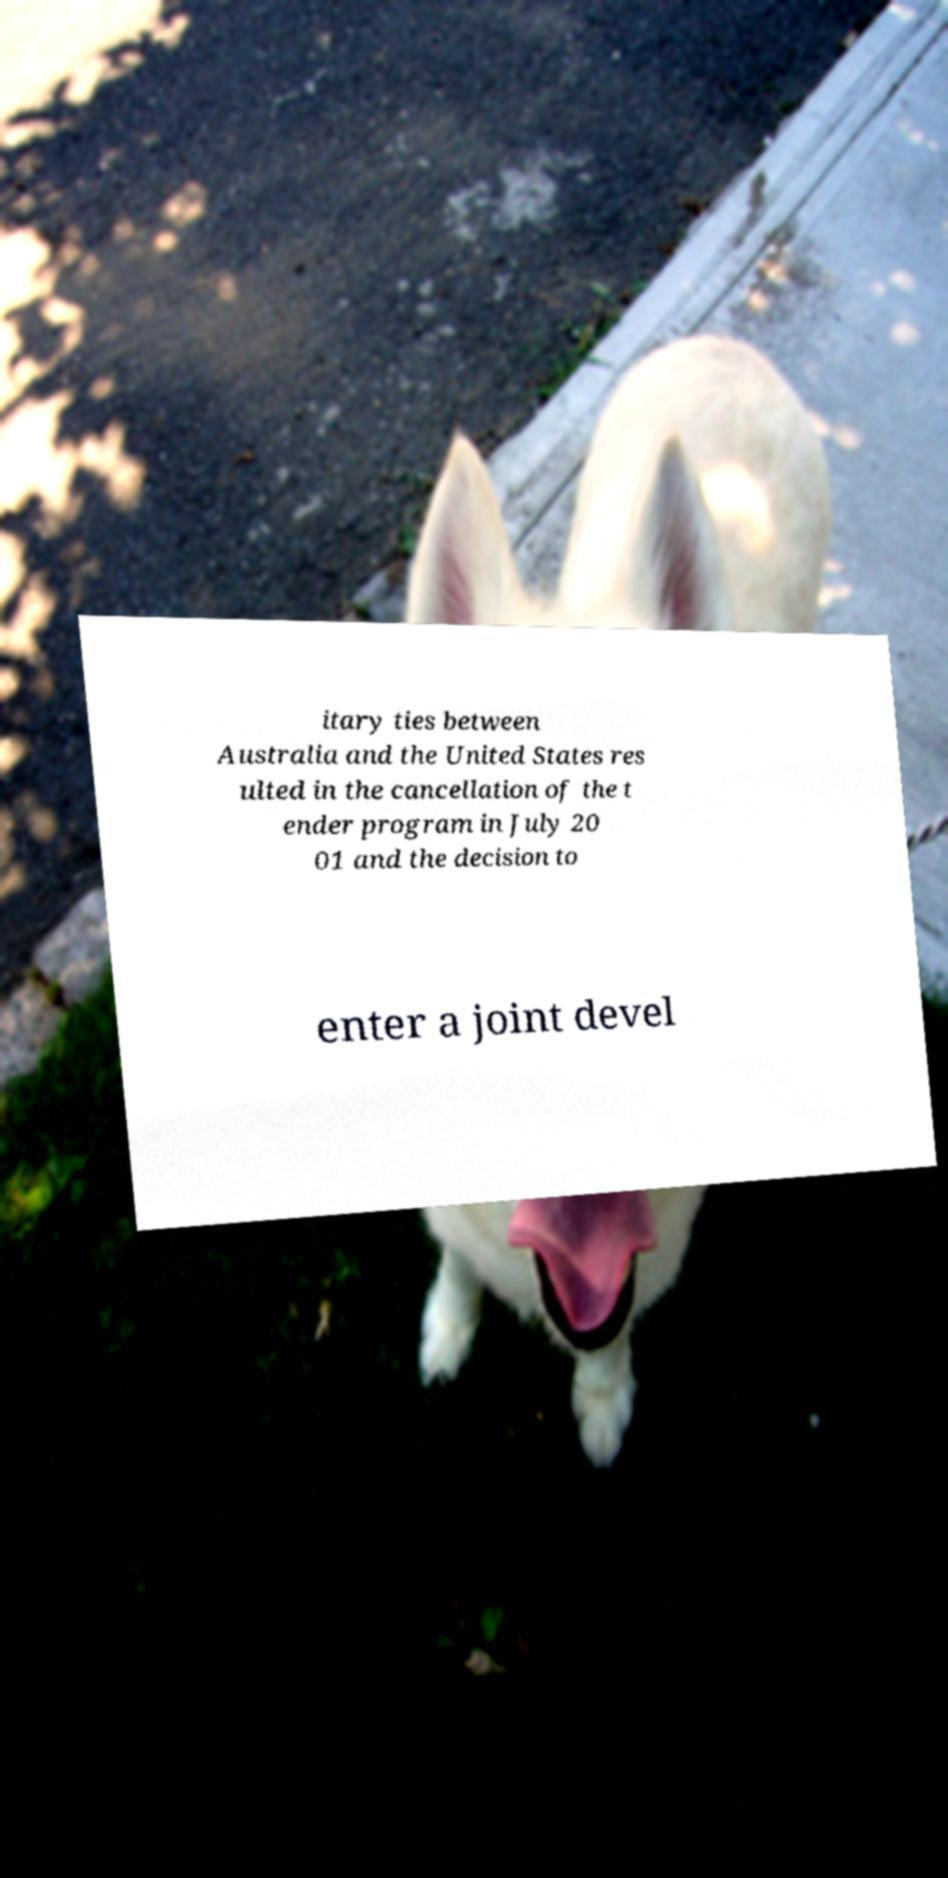Please identify and transcribe the text found in this image. itary ties between Australia and the United States res ulted in the cancellation of the t ender program in July 20 01 and the decision to enter a joint devel 